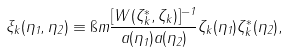Convert formula to latex. <formula><loc_0><loc_0><loc_500><loc_500>\xi _ { k } ( \eta _ { 1 } , \eta _ { 2 } ) \equiv \i m \frac { [ W ( \zeta ^ { \ast } _ { k } , \zeta _ { k } ) ] ^ { - 1 } } { a ( \eta _ { 1 } ) a ( \eta _ { 2 } ) } \zeta _ { k } ( \eta _ { 1 } ) \zeta ^ { \ast } _ { k } ( \eta _ { 2 } ) ,</formula> 